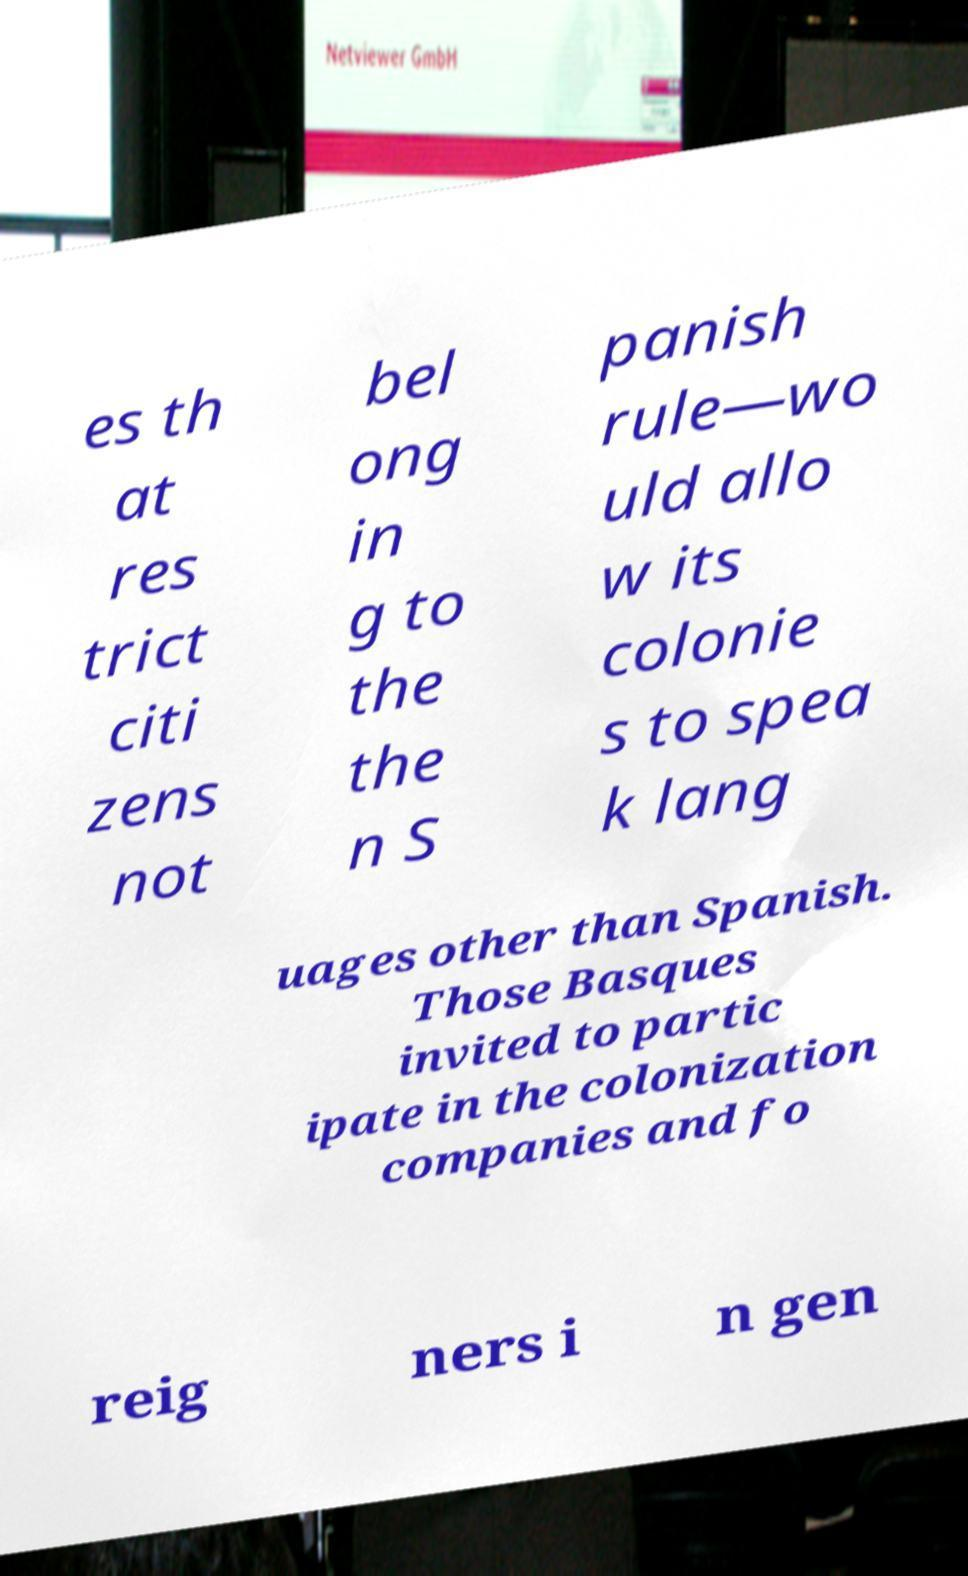Please read and relay the text visible in this image. What does it say? es th at res trict citi zens not bel ong in g to the the n S panish rule—wo uld allo w its colonie s to spea k lang uages other than Spanish. Those Basques invited to partic ipate in the colonization companies and fo reig ners i n gen 